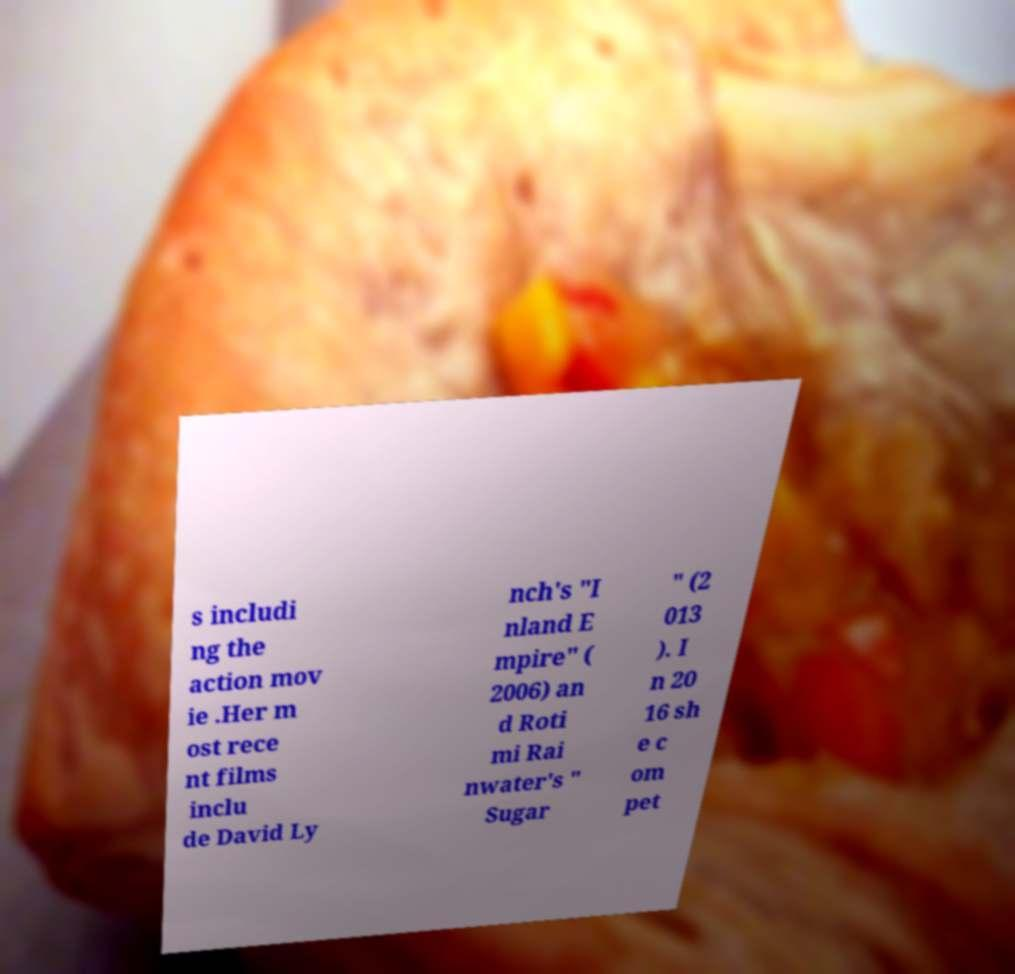Can you read and provide the text displayed in the image?This photo seems to have some interesting text. Can you extract and type it out for me? s includi ng the action mov ie .Her m ost rece nt films inclu de David Ly nch's "I nland E mpire" ( 2006) an d Roti mi Rai nwater's " Sugar " (2 013 ). I n 20 16 sh e c om pet 